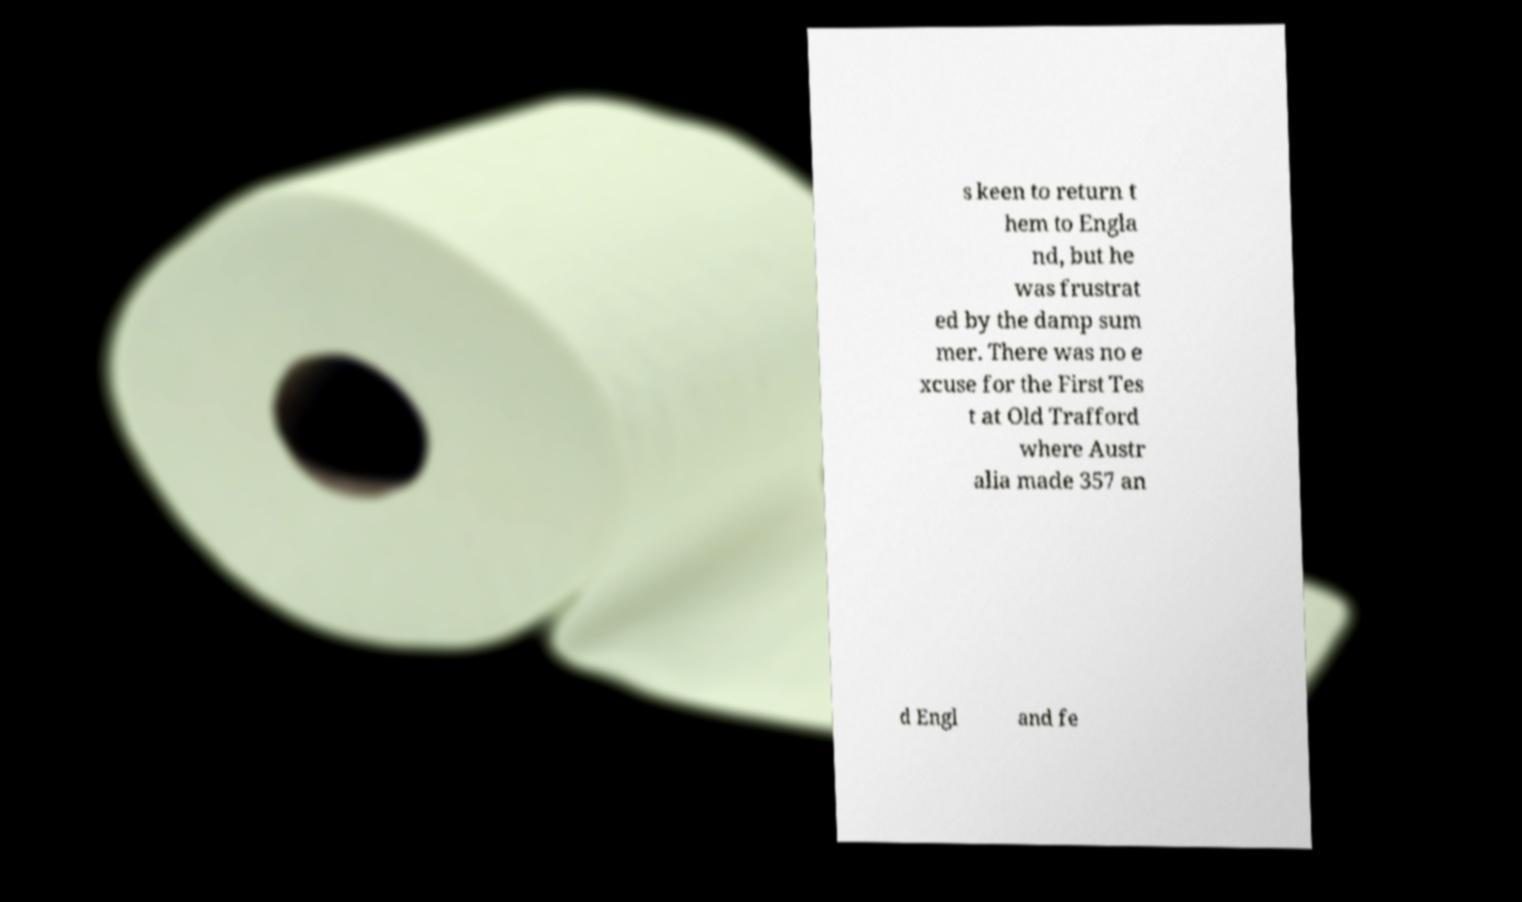Could you assist in decoding the text presented in this image and type it out clearly? s keen to return t hem to Engla nd, but he was frustrat ed by the damp sum mer. There was no e xcuse for the First Tes t at Old Trafford where Austr alia made 357 an d Engl and fe 